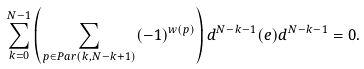<formula> <loc_0><loc_0><loc_500><loc_500>\sum _ { k = 0 } ^ { N - 1 } \left ( \sum _ { p \in P a r ( k , N - k + 1 ) } ( - 1 ) ^ { w ( p ) } \right ) d ^ { N - k - 1 } ( e ) d ^ { N - k - 1 } = 0 .</formula> 